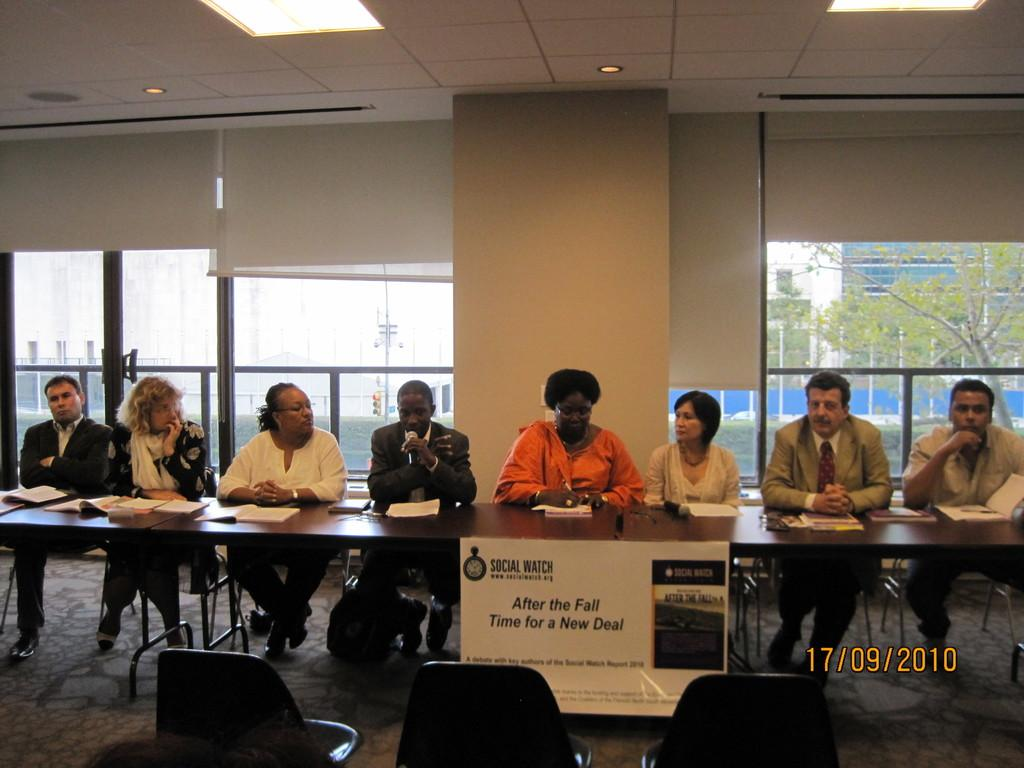What are the people in the image doing? The people in the image are sitting on chairs. What is present in the image besides the people? There is a table in the image. What is on the table in the image? There are papers on the table in the image. How many seeds are on the table in the image? There are no seeds present on the table in the image. Can you tell me the credit score of the person sitting on the left chair in the image? There is no information about credit scores in the image. 